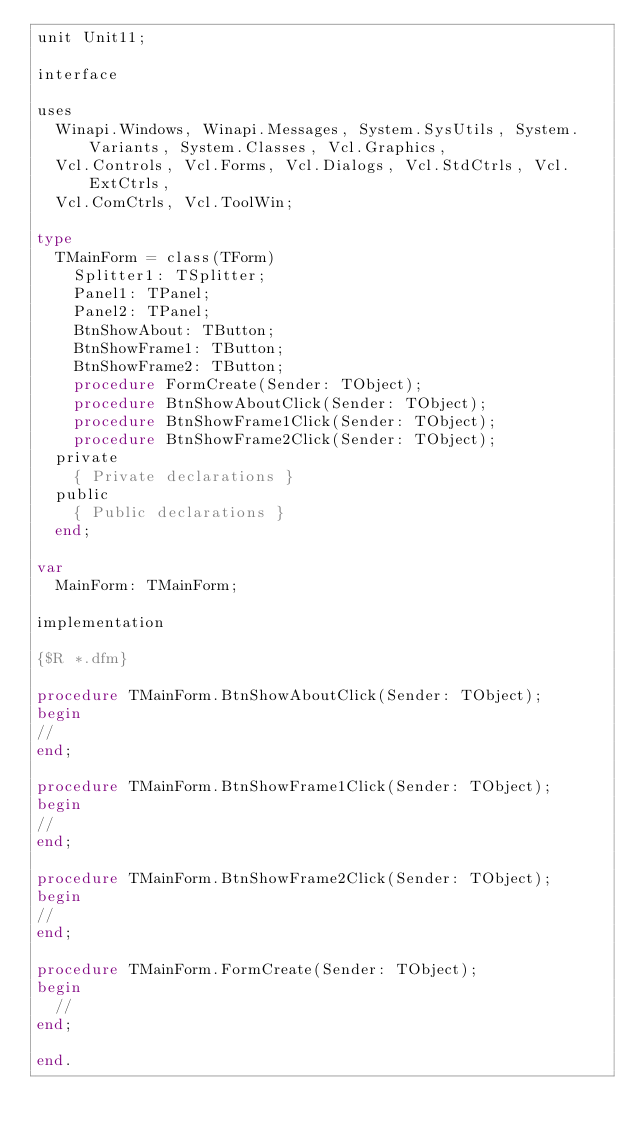Convert code to text. <code><loc_0><loc_0><loc_500><loc_500><_Pascal_>unit Unit11;

interface

uses
  Winapi.Windows, Winapi.Messages, System.SysUtils, System.Variants, System.Classes, Vcl.Graphics,
  Vcl.Controls, Vcl.Forms, Vcl.Dialogs, Vcl.StdCtrls, Vcl.ExtCtrls,
  Vcl.ComCtrls, Vcl.ToolWin;

type
  TMainForm = class(TForm)
    Splitter1: TSplitter;
    Panel1: TPanel;
    Panel2: TPanel;
    BtnShowAbout: TButton;
    BtnShowFrame1: TButton;
    BtnShowFrame2: TButton;
    procedure FormCreate(Sender: TObject);
    procedure BtnShowAboutClick(Sender: TObject);
    procedure BtnShowFrame1Click(Sender: TObject);
    procedure BtnShowFrame2Click(Sender: TObject);
  private
    { Private declarations }
  public
    { Public declarations }
  end;

var
  MainForm: TMainForm;

implementation

{$R *.dfm}

procedure TMainForm.BtnShowAboutClick(Sender: TObject);
begin
//
end;

procedure TMainForm.BtnShowFrame1Click(Sender: TObject);
begin
//
end;

procedure TMainForm.BtnShowFrame2Click(Sender: TObject);
begin
//
end;

procedure TMainForm.FormCreate(Sender: TObject);
begin
  //
end;

end.
</code> 